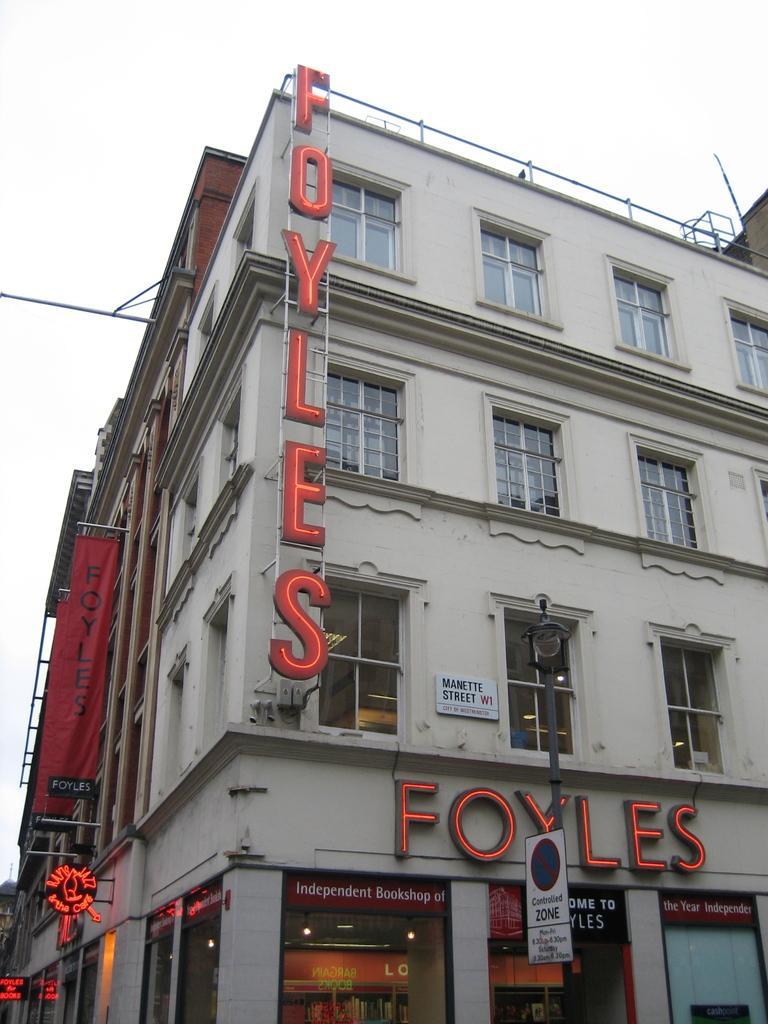Please provide a concise description of this image. In this image we can see a building with windows, a banner and a signboard. On the bottom of the image we can see some name boards with some text on it and a sign board to a pole. On the backside we can see the sky. 